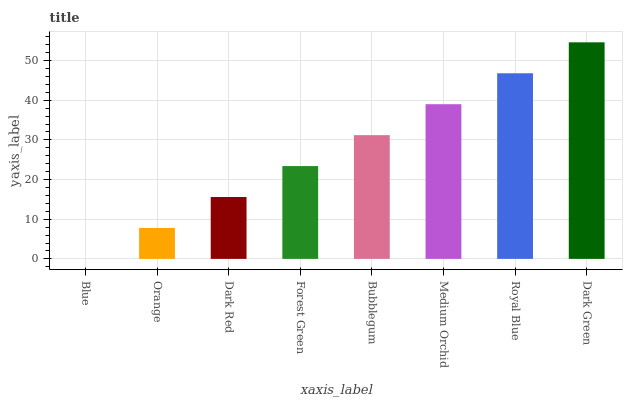Is Blue the minimum?
Answer yes or no. Yes. Is Dark Green the maximum?
Answer yes or no. Yes. Is Orange the minimum?
Answer yes or no. No. Is Orange the maximum?
Answer yes or no. No. Is Orange greater than Blue?
Answer yes or no. Yes. Is Blue less than Orange?
Answer yes or no. Yes. Is Blue greater than Orange?
Answer yes or no. No. Is Orange less than Blue?
Answer yes or no. No. Is Bubblegum the high median?
Answer yes or no. Yes. Is Forest Green the low median?
Answer yes or no. Yes. Is Orange the high median?
Answer yes or no. No. Is Orange the low median?
Answer yes or no. No. 